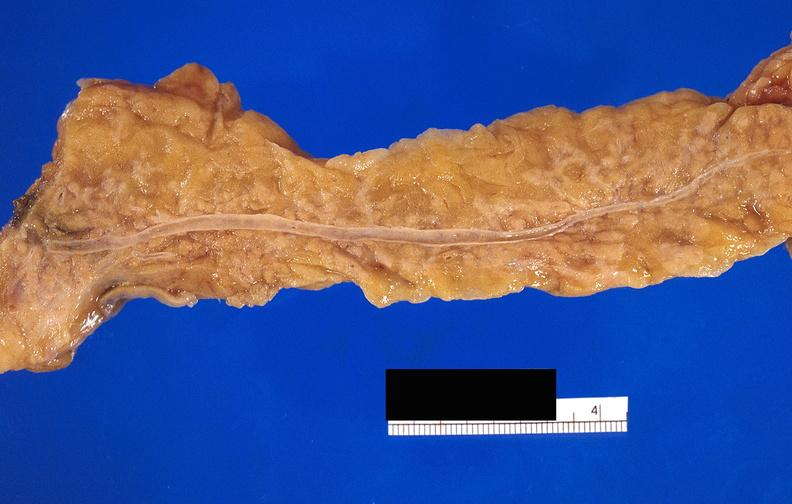does this image show pancreatic fat necrosis?
Answer the question using a single word or phrase. Yes 